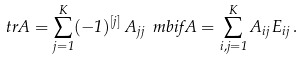<formula> <loc_0><loc_0><loc_500><loc_500>\ t r A = \sum _ { j = 1 } ^ { K } ( - 1 ) ^ { [ j ] } \, A _ { j j } \ m b { i f } A = \sum _ { i , j = 1 } ^ { K } A _ { i j } \, E _ { i j } \, .</formula> 